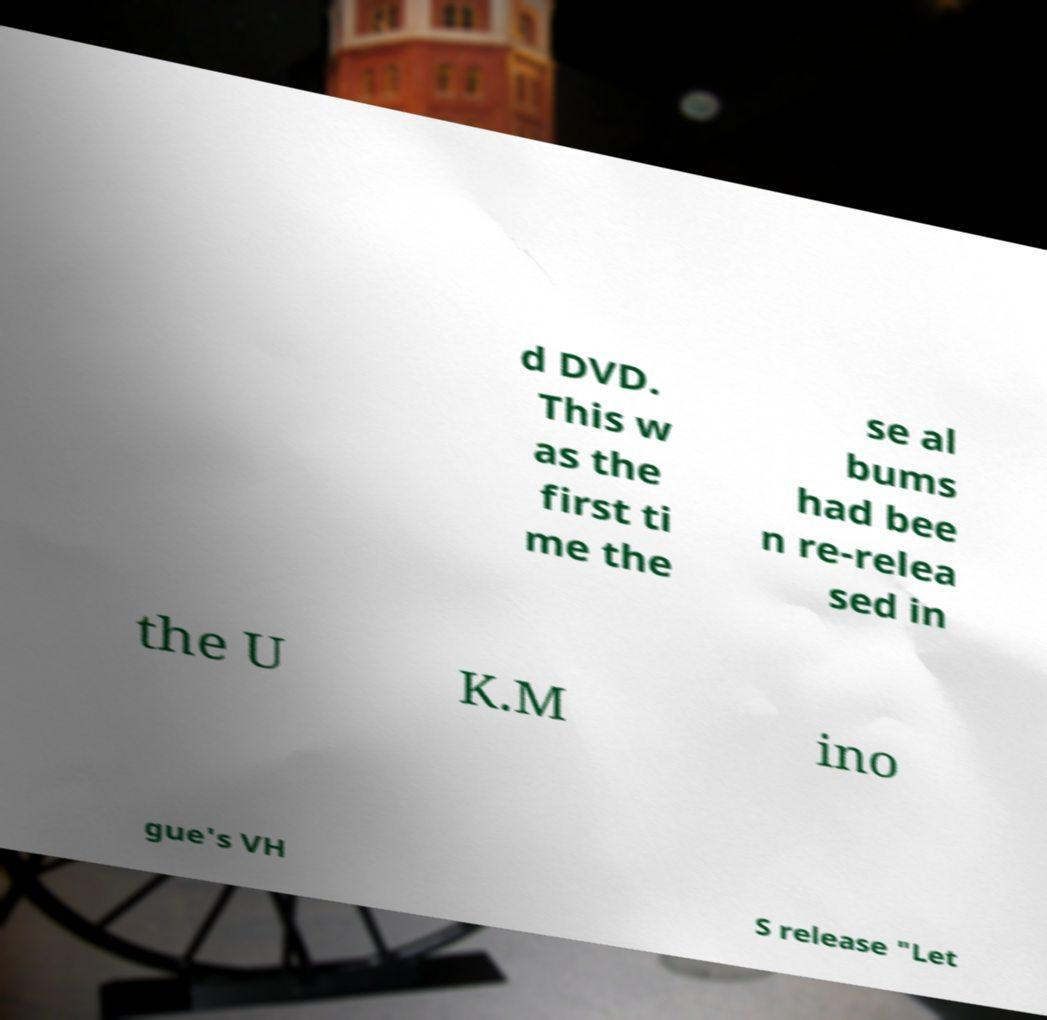There's text embedded in this image that I need extracted. Can you transcribe it verbatim? d DVD. This w as the first ti me the se al bums had bee n re-relea sed in the U K.M ino gue's VH S release "Let 